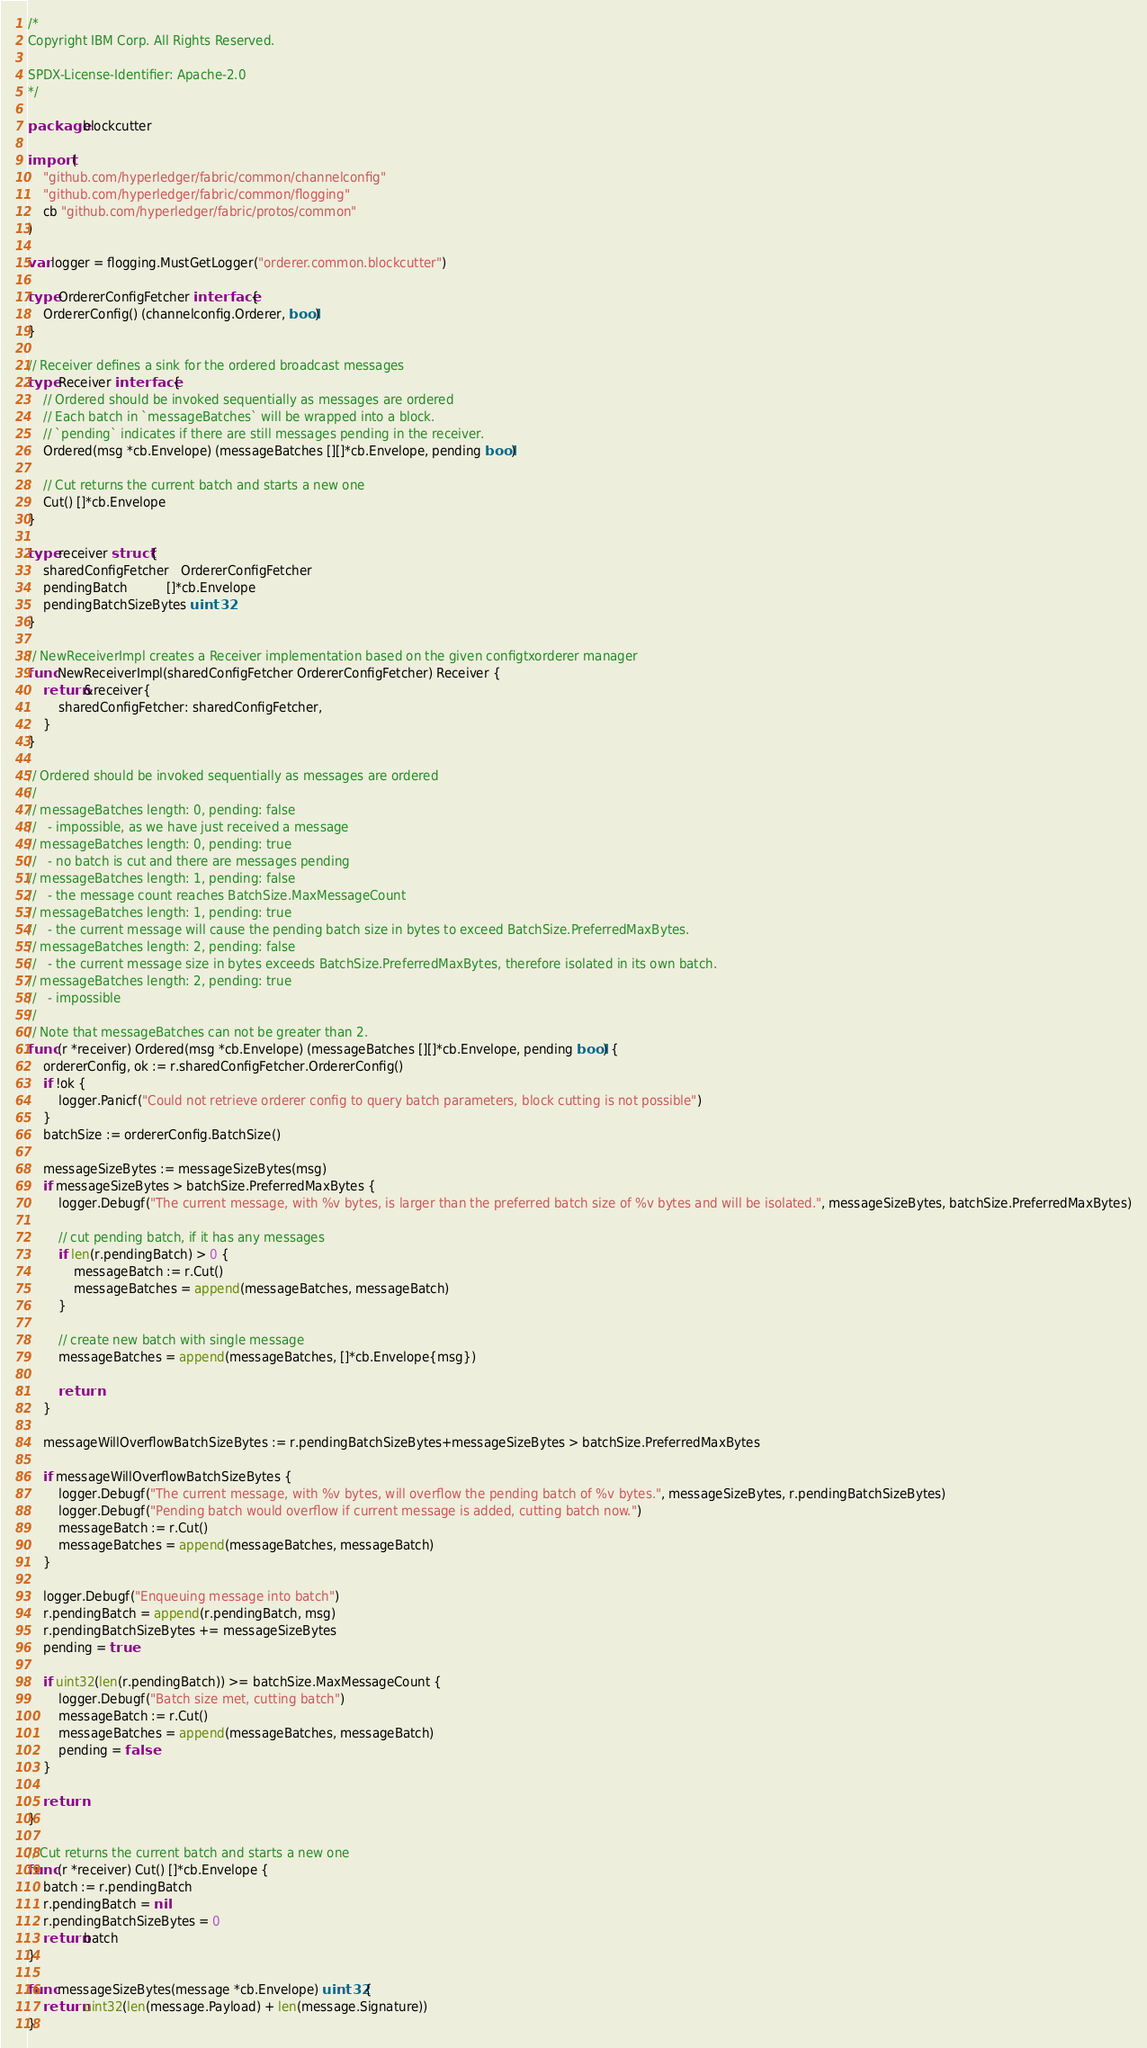Convert code to text. <code><loc_0><loc_0><loc_500><loc_500><_Go_>/*
Copyright IBM Corp. All Rights Reserved.

SPDX-License-Identifier: Apache-2.0
*/

package blockcutter

import (
	"github.com/hyperledger/fabric/common/channelconfig"
	"github.com/hyperledger/fabric/common/flogging"
	cb "github.com/hyperledger/fabric/protos/common"
)

var logger = flogging.MustGetLogger("orderer.common.blockcutter")

type OrdererConfigFetcher interface {
	OrdererConfig() (channelconfig.Orderer, bool)
}

// Receiver defines a sink for the ordered broadcast messages
type Receiver interface {
	// Ordered should be invoked sequentially as messages are ordered
	// Each batch in `messageBatches` will be wrapped into a block.
	// `pending` indicates if there are still messages pending in the receiver.
	Ordered(msg *cb.Envelope) (messageBatches [][]*cb.Envelope, pending bool)

	// Cut returns the current batch and starts a new one
	Cut() []*cb.Envelope
}

type receiver struct {
	sharedConfigFetcher   OrdererConfigFetcher
	pendingBatch          []*cb.Envelope
	pendingBatchSizeBytes uint32
}

// NewReceiverImpl creates a Receiver implementation based on the given configtxorderer manager
func NewReceiverImpl(sharedConfigFetcher OrdererConfigFetcher) Receiver {
	return &receiver{
		sharedConfigFetcher: sharedConfigFetcher,
	}
}

// Ordered should be invoked sequentially as messages are ordered
//
// messageBatches length: 0, pending: false
//   - impossible, as we have just received a message
// messageBatches length: 0, pending: true
//   - no batch is cut and there are messages pending
// messageBatches length: 1, pending: false
//   - the message count reaches BatchSize.MaxMessageCount
// messageBatches length: 1, pending: true
//   - the current message will cause the pending batch size in bytes to exceed BatchSize.PreferredMaxBytes.
// messageBatches length: 2, pending: false
//   - the current message size in bytes exceeds BatchSize.PreferredMaxBytes, therefore isolated in its own batch.
// messageBatches length: 2, pending: true
//   - impossible
//
// Note that messageBatches can not be greater than 2.
func (r *receiver) Ordered(msg *cb.Envelope) (messageBatches [][]*cb.Envelope, pending bool) {
	ordererConfig, ok := r.sharedConfigFetcher.OrdererConfig()
	if !ok {
		logger.Panicf("Could not retrieve orderer config to query batch parameters, block cutting is not possible")
	}
	batchSize := ordererConfig.BatchSize()

	messageSizeBytes := messageSizeBytes(msg)
	if messageSizeBytes > batchSize.PreferredMaxBytes {
		logger.Debugf("The current message, with %v bytes, is larger than the preferred batch size of %v bytes and will be isolated.", messageSizeBytes, batchSize.PreferredMaxBytes)

		// cut pending batch, if it has any messages
		if len(r.pendingBatch) > 0 {
			messageBatch := r.Cut()
			messageBatches = append(messageBatches, messageBatch)
		}

		// create new batch with single message
		messageBatches = append(messageBatches, []*cb.Envelope{msg})

		return
	}

	messageWillOverflowBatchSizeBytes := r.pendingBatchSizeBytes+messageSizeBytes > batchSize.PreferredMaxBytes

	if messageWillOverflowBatchSizeBytes {
		logger.Debugf("The current message, with %v bytes, will overflow the pending batch of %v bytes.", messageSizeBytes, r.pendingBatchSizeBytes)
		logger.Debugf("Pending batch would overflow if current message is added, cutting batch now.")
		messageBatch := r.Cut()
		messageBatches = append(messageBatches, messageBatch)
	}

	logger.Debugf("Enqueuing message into batch")
	r.pendingBatch = append(r.pendingBatch, msg)
	r.pendingBatchSizeBytes += messageSizeBytes
	pending = true

	if uint32(len(r.pendingBatch)) >= batchSize.MaxMessageCount {
		logger.Debugf("Batch size met, cutting batch")
		messageBatch := r.Cut()
		messageBatches = append(messageBatches, messageBatch)
		pending = false
	}

	return
}

// Cut returns the current batch and starts a new one
func (r *receiver) Cut() []*cb.Envelope {
	batch := r.pendingBatch
	r.pendingBatch = nil
	r.pendingBatchSizeBytes = 0
	return batch
}

func messageSizeBytes(message *cb.Envelope) uint32 {
	return uint32(len(message.Payload) + len(message.Signature))
}
</code> 